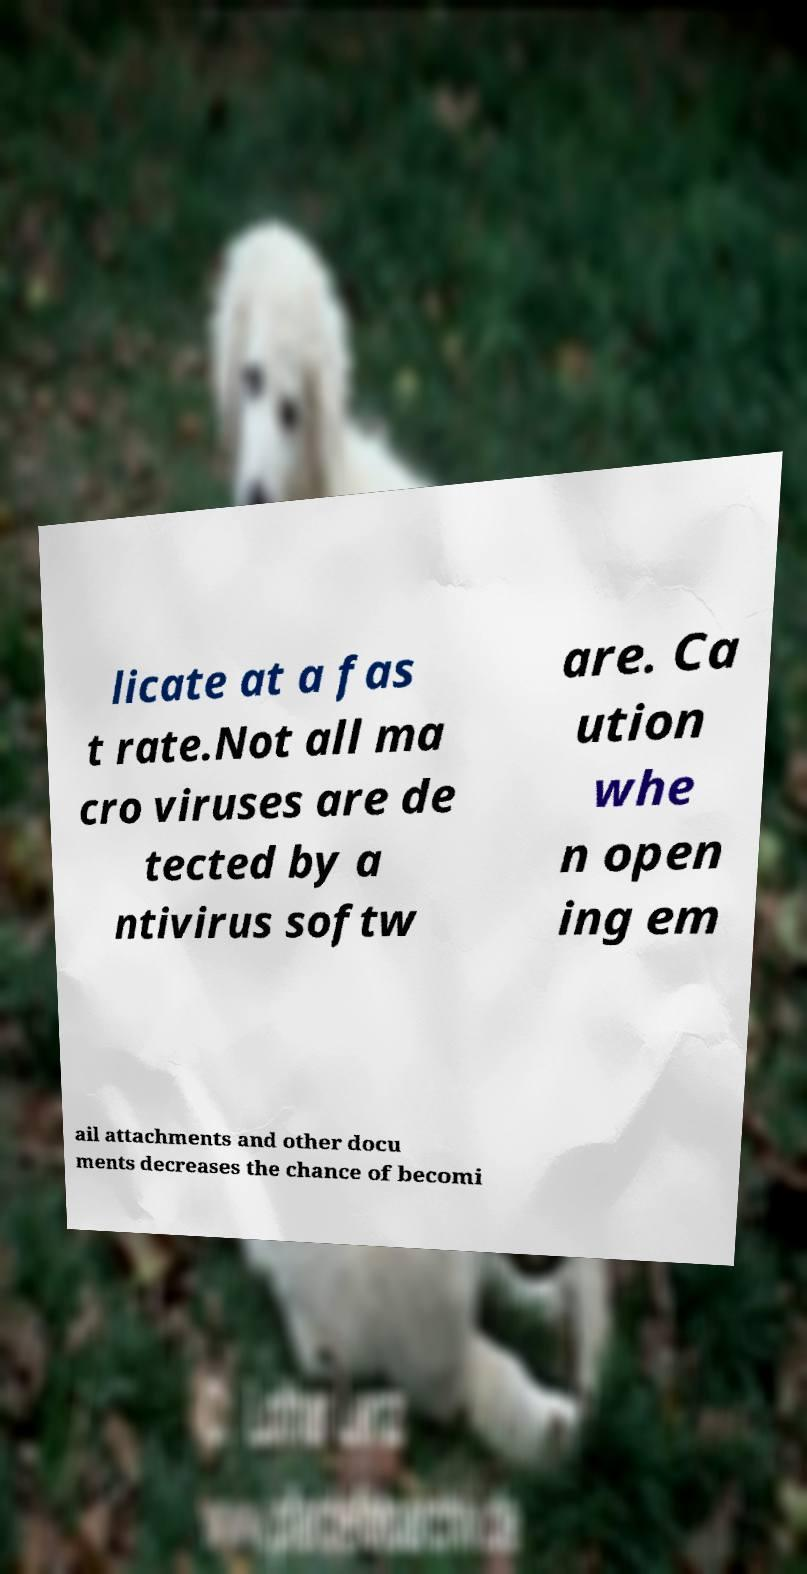Please identify and transcribe the text found in this image. licate at a fas t rate.Not all ma cro viruses are de tected by a ntivirus softw are. Ca ution whe n open ing em ail attachments and other docu ments decreases the chance of becomi 